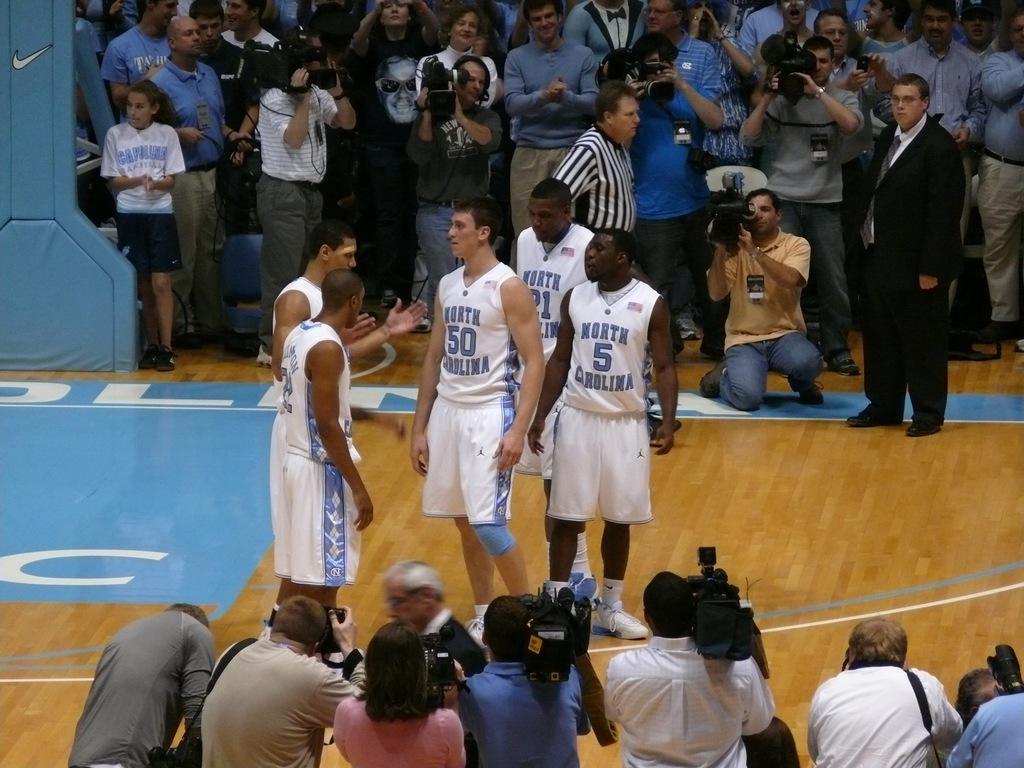Could you give a brief overview of what you see in this image? In this image I can see some people. In the top left corner, I can see a pillar. 